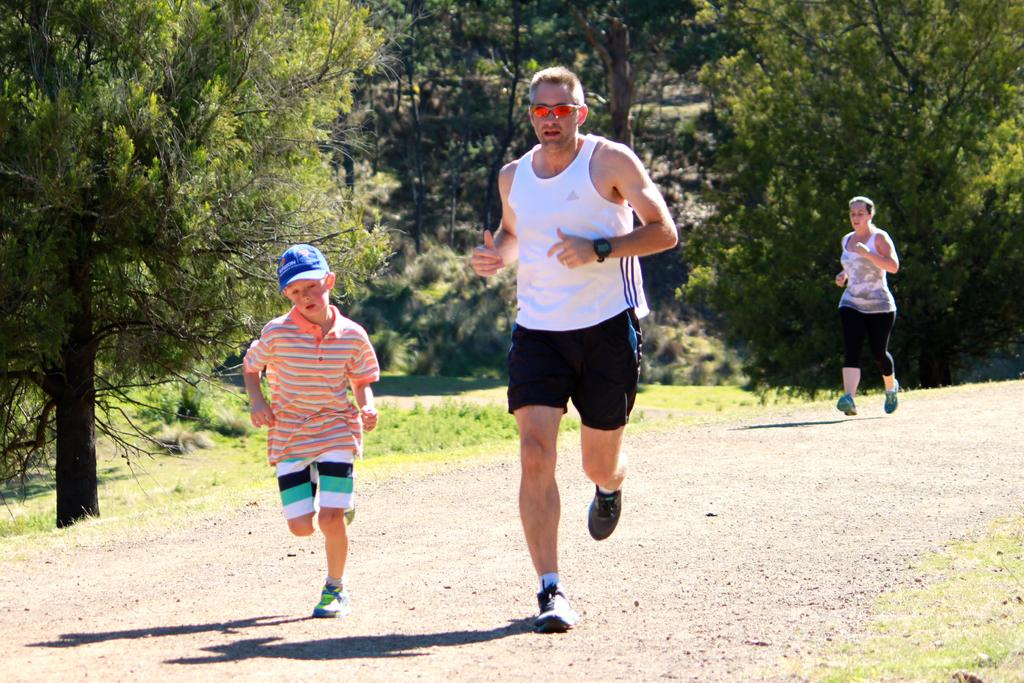How many people are in the image? There are three persons in the image. What are the persons doing in the image? The persons are running. What can be seen in the background of the image? There are trees and grass in the background of the image. What is at the bottom of the image? There is a road and grass at the bottom of the image. Can you tell me how many kites are being flown by the persons in the image? There are no kites visible in the image; the persons are running. What type of bird can be seen perched on the wren in the image? There is no wren present in the image. 